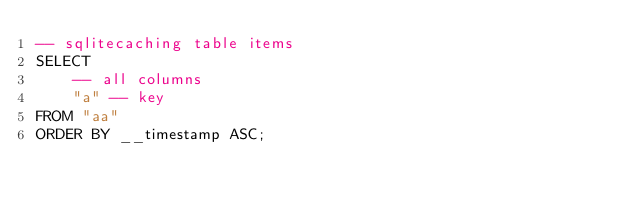<code> <loc_0><loc_0><loc_500><loc_500><_SQL_>-- sqlitecaching table items
SELECT
    -- all columns
    "a" -- key
FROM "aa"
ORDER BY __timestamp ASC;
</code> 